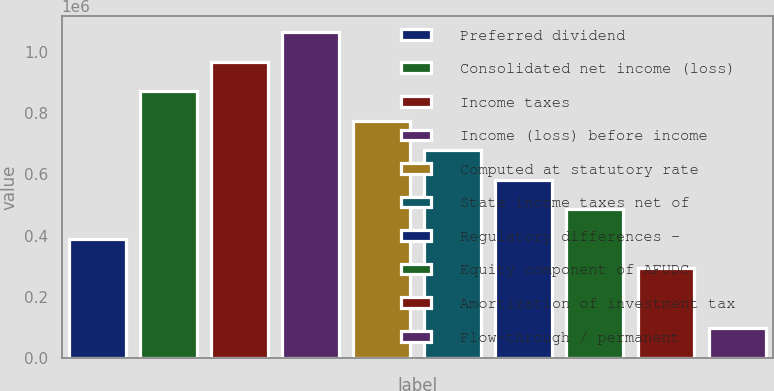Convert chart. <chart><loc_0><loc_0><loc_500><loc_500><bar_chart><fcel>Preferred dividend<fcel>Consolidated net income (loss)<fcel>Income taxes<fcel>Income (loss) before income<fcel>Computed at statutory rate<fcel>State income taxes net of<fcel>Regulatory differences -<fcel>Equity component of AFUDC<fcel>Amortization of investment tax<fcel>Flow-through / permanent<nl><fcel>388973<fcel>871431<fcel>967923<fcel>1.06441e+06<fcel>774940<fcel>678448<fcel>581957<fcel>485465<fcel>292482<fcel>99498.6<nl></chart> 